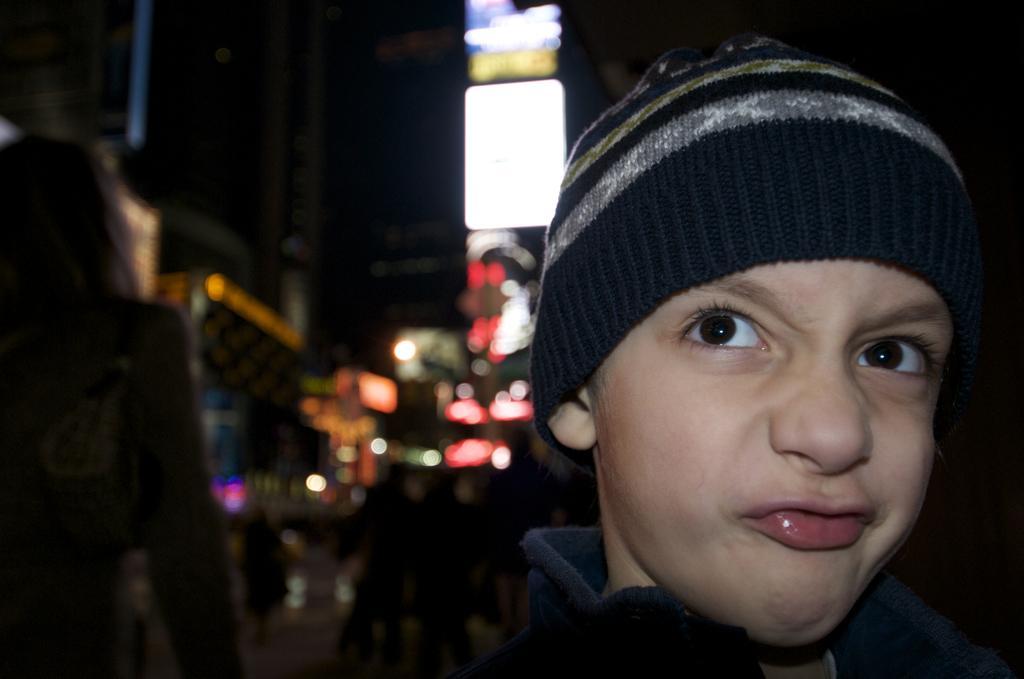Please provide a concise description of this image. In this image we can see a kid with skullcap, behind him there are few other persons, buildings and some lights, and the background is blurred. 